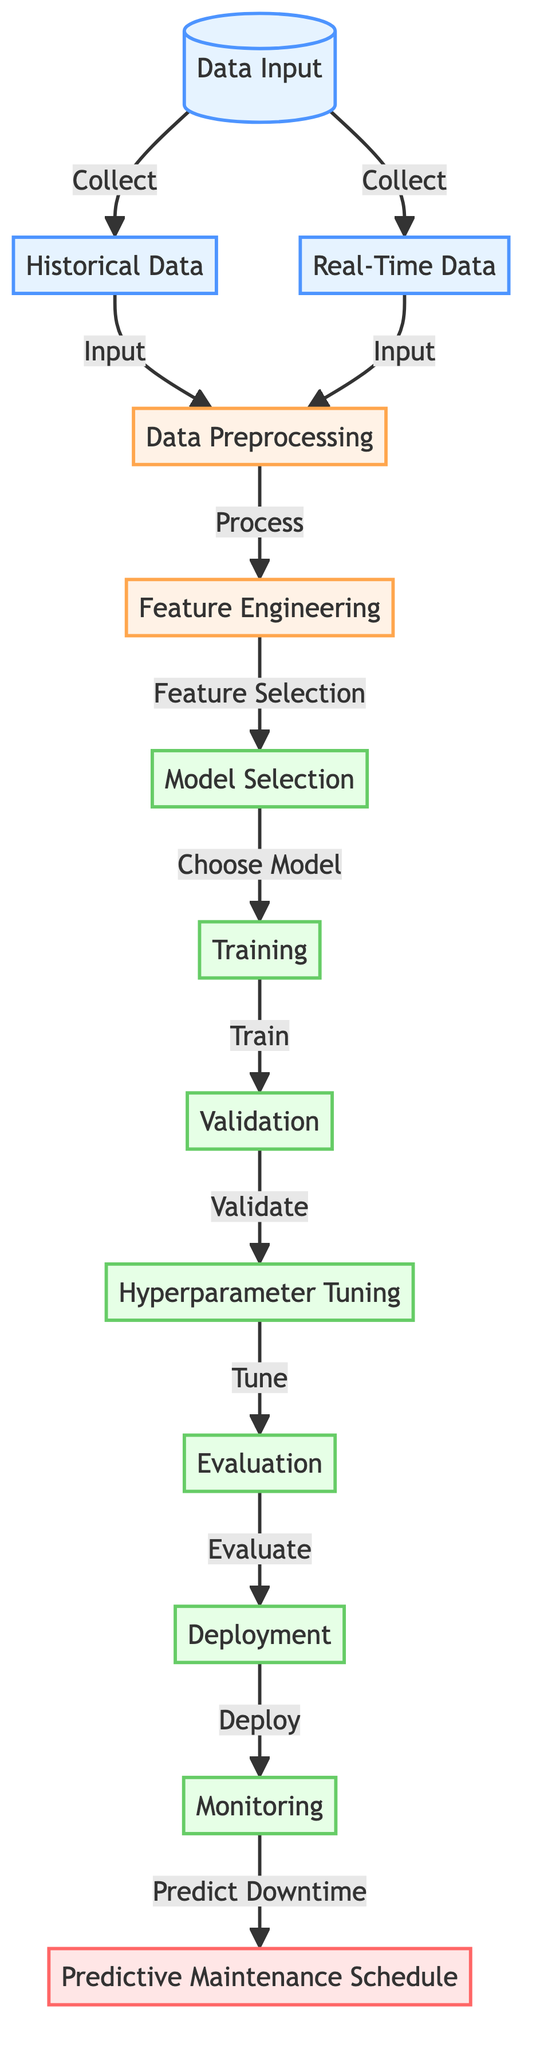What are the inputs to the Data Preprocessing stage? The inputs to the Data Preprocessing stage are Historical Data and Real-Time Data. This is indicated by the arrows leading to the Data Preprocessing node from these two nodes.
Answer: Historical Data and Real-Time Data How many model nodes are present in the diagram? The model nodes are Model Selection, Training, Validation, Hyperparameter Tuning, Evaluation, Deployment, and Monitoring. Counting these nodes provides the total, which is seven model nodes.
Answer: Seven What is the output of the Monitoring stage? The output of the Monitoring stage is the Predictive Maintenance Schedule. This is shown by the arrow leading from the Monitoring node to Maintenance Schedule node, which signifies the output.
Answer: Predictive Maintenance Schedule Which node comes directly after Feature Engineering? The node that comes directly after Feature Engineering is Model Selection. This is evident from the arrow connecting Feature Engineering to Model Selection in the flowchart.
Answer: Model Selection What process follows the Training stage before the final output? The process that follows the Training stage before the final output is Validation. This can be seen from the direct path indicated by an arrow leading from Training to Validation.
Answer: Validation What step is taken to prepare the features in the model training process? The step taken to prepare the features is Feature Selection. This is indicated by the arrow from Feature Engineering pointing to Model Selection, indicating that features have been selected for model usage.
Answer: Feature Selection Which step is taken to ensure model accuracy before Deployment? The step taken to ensure model accuracy before Deployment is Evaluation. This is evidenced by the diagram flow that moves from Hyperparameter Tuning to Evaluation before Deployment.
Answer: Evaluation Which node collects data from both Historical and Real-Time inputs? The node that collects data from both Historical and Real-Time inputs is Data Input. This is indicated by the two arrows that originate from Data Input and lead to the Historical Data and Real-Time Data nodes.
Answer: Data Input What is the primary purpose of the diagram? The primary purpose of the diagram is to illustrate the process of utilizing machine learning to forecast equipment downtime. This purpose is encapsulated in the title and the flow layout showing the various processes leading to a maintenance schedule.
Answer: Forecast equipment downtime 